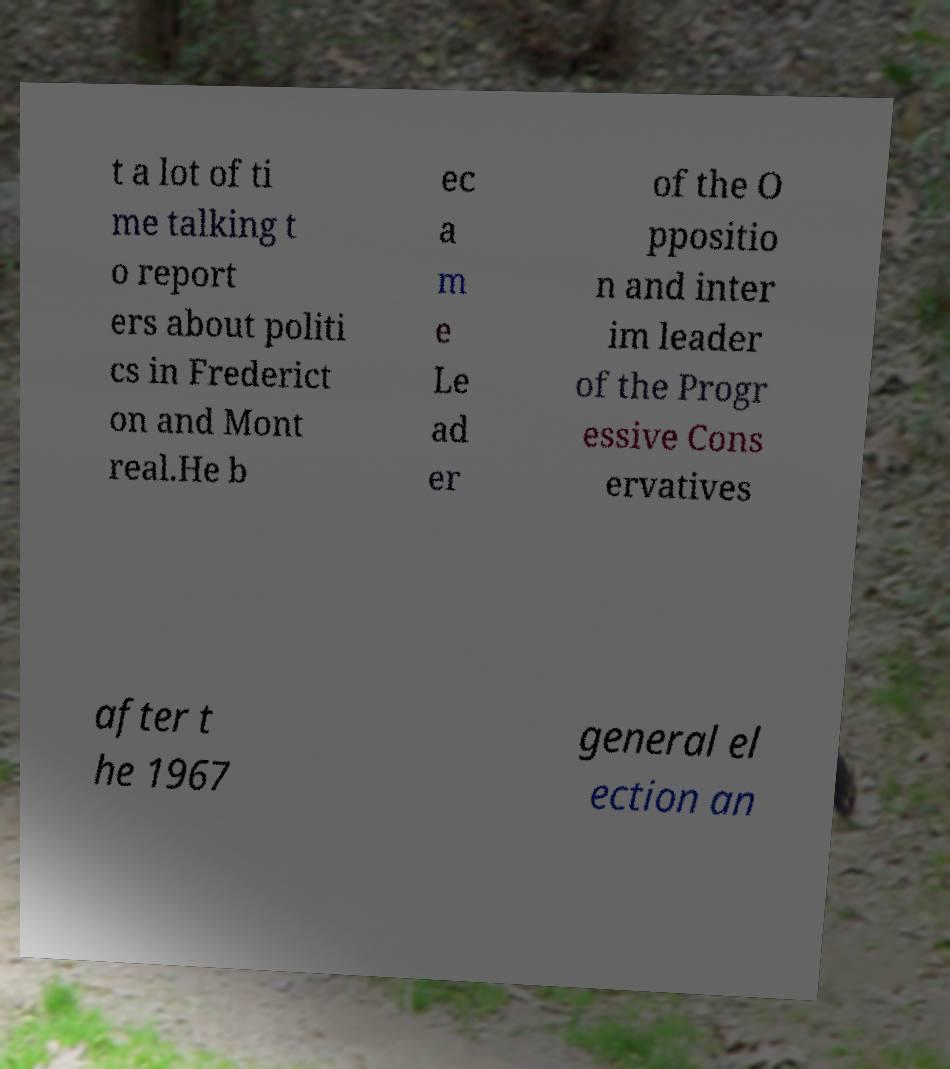Can you read and provide the text displayed in the image?This photo seems to have some interesting text. Can you extract and type it out for me? t a lot of ti me talking t o report ers about politi cs in Frederict on and Mont real.He b ec a m e Le ad er of the O ppositio n and inter im leader of the Progr essive Cons ervatives after t he 1967 general el ection an 